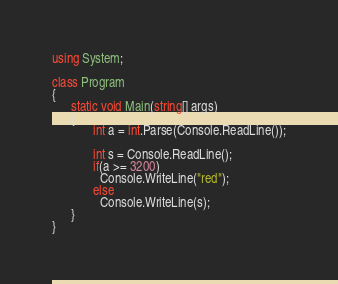<code> <loc_0><loc_0><loc_500><loc_500><_C#_>using System;

class Program
{
      static void Main(string[] args)
      {
             int a = int.Parse(Console.ReadLine());
        
             int s = Console.ReadLine();
             if(a >= 3200)
               Console.WriteLine("red");
             else
               Console.WriteLine(s);
      }
}</code> 